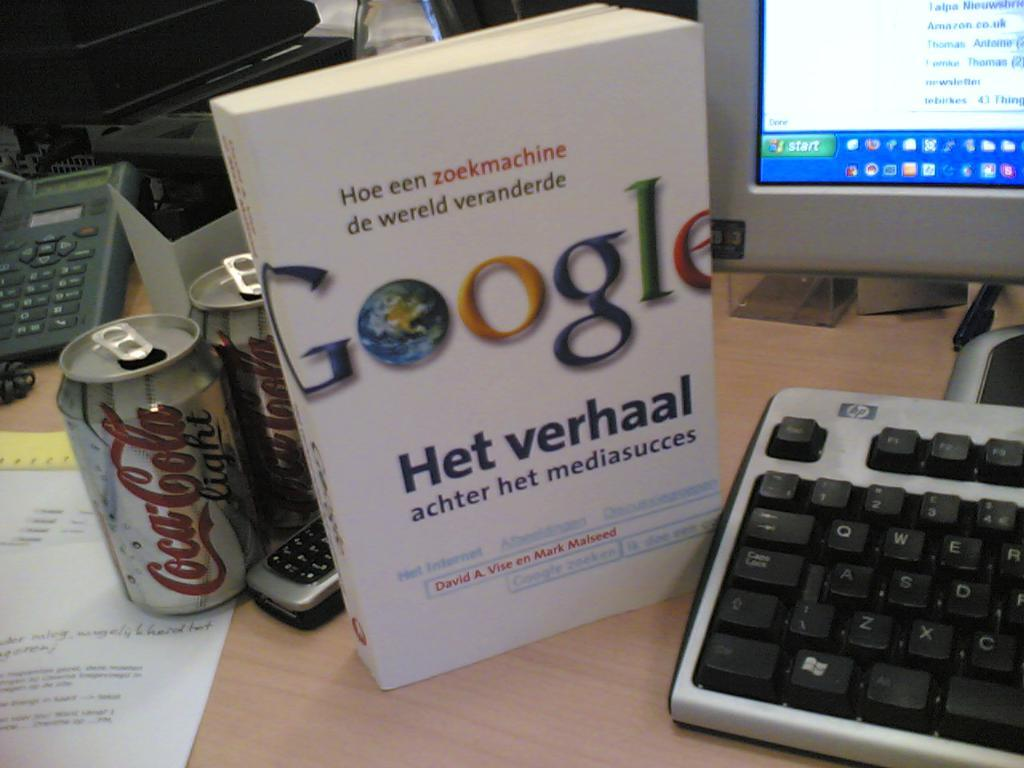<image>
Create a compact narrative representing the image presented. A Google Het Verhaal book about Hoe een zoekmachine de wereld veranderde stands up next to a coca cola can and computer. 